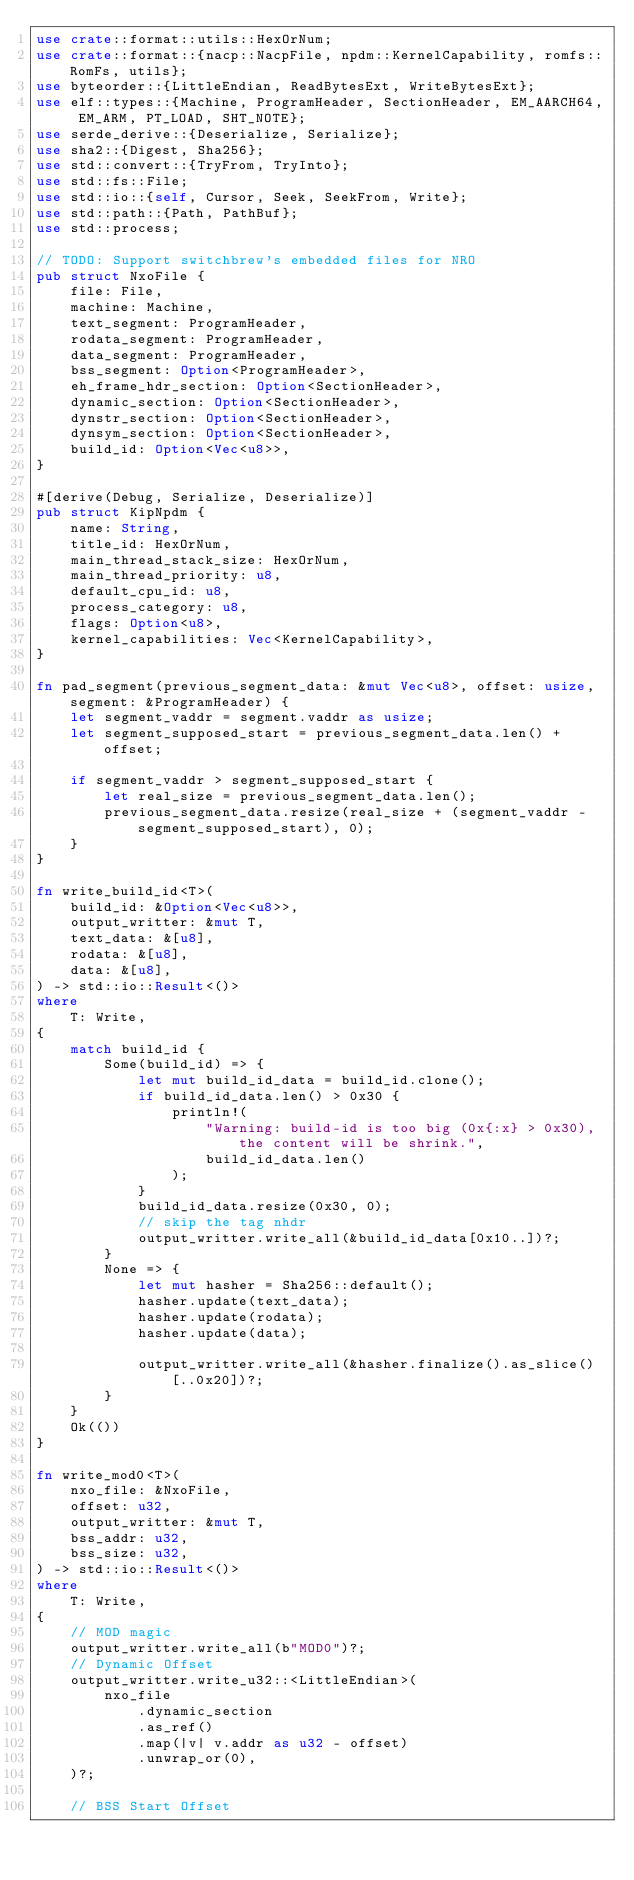<code> <loc_0><loc_0><loc_500><loc_500><_Rust_>use crate::format::utils::HexOrNum;
use crate::format::{nacp::NacpFile, npdm::KernelCapability, romfs::RomFs, utils};
use byteorder::{LittleEndian, ReadBytesExt, WriteBytesExt};
use elf::types::{Machine, ProgramHeader, SectionHeader, EM_AARCH64, EM_ARM, PT_LOAD, SHT_NOTE};
use serde_derive::{Deserialize, Serialize};
use sha2::{Digest, Sha256};
use std::convert::{TryFrom, TryInto};
use std::fs::File;
use std::io::{self, Cursor, Seek, SeekFrom, Write};
use std::path::{Path, PathBuf};
use std::process;

// TODO: Support switchbrew's embedded files for NRO
pub struct NxoFile {
    file: File,
    machine: Machine,
    text_segment: ProgramHeader,
    rodata_segment: ProgramHeader,
    data_segment: ProgramHeader,
    bss_segment: Option<ProgramHeader>,
    eh_frame_hdr_section: Option<SectionHeader>,
    dynamic_section: Option<SectionHeader>,
    dynstr_section: Option<SectionHeader>,
    dynsym_section: Option<SectionHeader>,
    build_id: Option<Vec<u8>>,
}

#[derive(Debug, Serialize, Deserialize)]
pub struct KipNpdm {
    name: String,
    title_id: HexOrNum,
    main_thread_stack_size: HexOrNum,
    main_thread_priority: u8,
    default_cpu_id: u8,
    process_category: u8,
    flags: Option<u8>,
    kernel_capabilities: Vec<KernelCapability>,
}

fn pad_segment(previous_segment_data: &mut Vec<u8>, offset: usize, segment: &ProgramHeader) {
    let segment_vaddr = segment.vaddr as usize;
    let segment_supposed_start = previous_segment_data.len() + offset;

    if segment_vaddr > segment_supposed_start {
        let real_size = previous_segment_data.len();
        previous_segment_data.resize(real_size + (segment_vaddr - segment_supposed_start), 0);
    }
}

fn write_build_id<T>(
    build_id: &Option<Vec<u8>>,
    output_writter: &mut T,
    text_data: &[u8],
    rodata: &[u8],
    data: &[u8],
) -> std::io::Result<()>
where
    T: Write,
{
    match build_id {
        Some(build_id) => {
            let mut build_id_data = build_id.clone();
            if build_id_data.len() > 0x30 {
                println!(
                    "Warning: build-id is too big (0x{:x} > 0x30), the content will be shrink.",
                    build_id_data.len()
                );
            }
            build_id_data.resize(0x30, 0);
            // skip the tag nhdr
            output_writter.write_all(&build_id_data[0x10..])?;
        }
        None => {
            let mut hasher = Sha256::default();
            hasher.update(text_data);
            hasher.update(rodata);
            hasher.update(data);

            output_writter.write_all(&hasher.finalize().as_slice()[..0x20])?;
        }
    }
    Ok(())
}

fn write_mod0<T>(
    nxo_file: &NxoFile,
    offset: u32,
    output_writter: &mut T,
    bss_addr: u32,
    bss_size: u32,
) -> std::io::Result<()>
where
    T: Write,
{
    // MOD magic
    output_writter.write_all(b"MOD0")?;
    // Dynamic Offset
    output_writter.write_u32::<LittleEndian>(
        nxo_file
            .dynamic_section
            .as_ref()
            .map(|v| v.addr as u32 - offset)
            .unwrap_or(0),
    )?;

    // BSS Start Offset</code> 